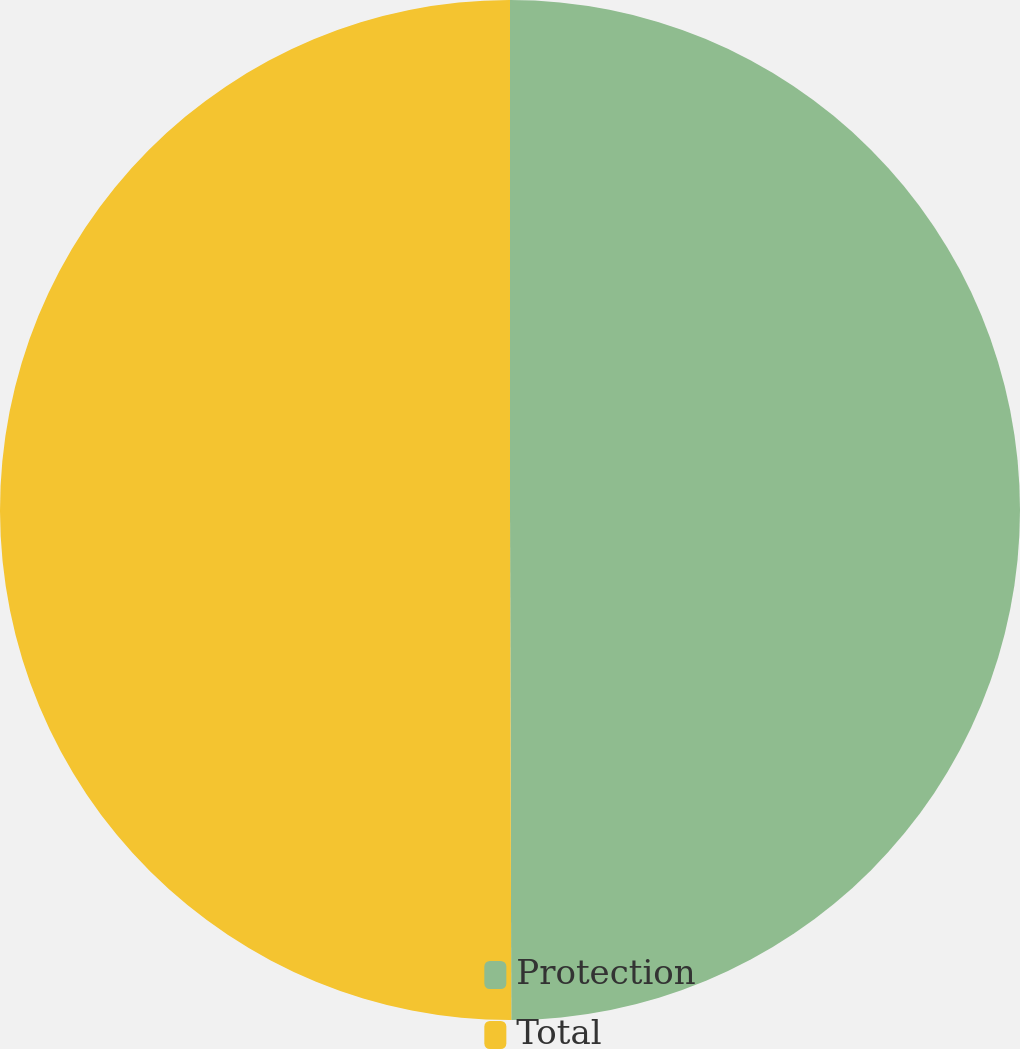<chart> <loc_0><loc_0><loc_500><loc_500><pie_chart><fcel>Protection<fcel>Total<nl><fcel>49.96%<fcel>50.04%<nl></chart> 